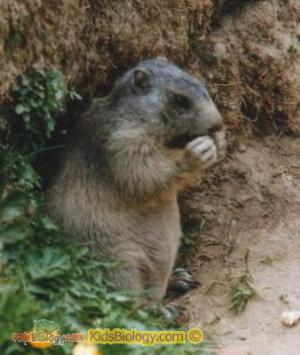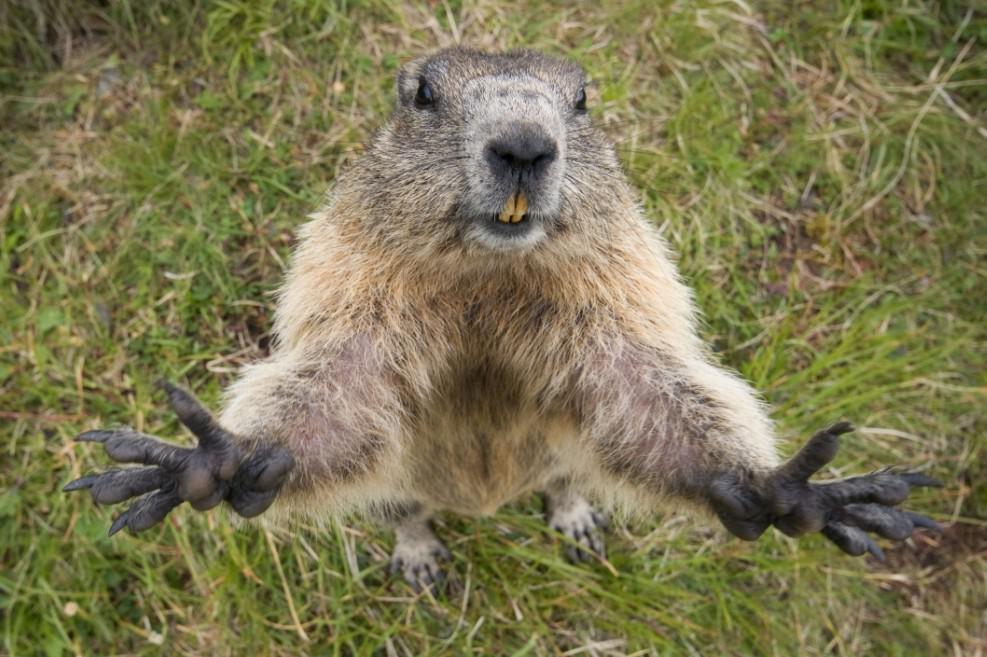The first image is the image on the left, the second image is the image on the right. Considering the images on both sides, is "There are at least two animals in the image on the right." valid? Answer yes or no. No. The first image is the image on the left, the second image is the image on the right. Considering the images on both sides, is "There is only one animal is eating." valid? Answer yes or no. Yes. 